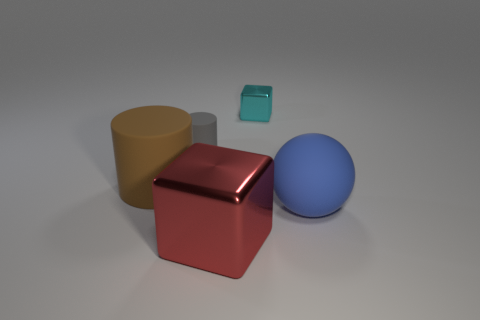Are there any other things that have the same material as the large blue thing?
Provide a succinct answer. Yes. There is a object that is both behind the brown matte cylinder and in front of the tiny cube; what is its shape?
Keep it short and to the point. Cylinder. What number of other things are there of the same shape as the large blue matte object?
Provide a short and direct response. 0. What size is the blue thing?
Keep it short and to the point. Large. What number of objects are cyan blocks or large cylinders?
Provide a succinct answer. 2. How big is the metallic thing that is behind the gray matte thing?
Your response must be concise. Small. The object that is in front of the tiny gray rubber cylinder and behind the large blue thing is what color?
Make the answer very short. Brown. Do the cube that is behind the matte sphere and the large block have the same material?
Your answer should be compact. Yes. Are there any tiny objects left of the small cyan thing?
Provide a short and direct response. Yes. There is a metallic block that is behind the brown object; does it have the same size as the ball to the right of the large red metal cube?
Ensure brevity in your answer.  No. 